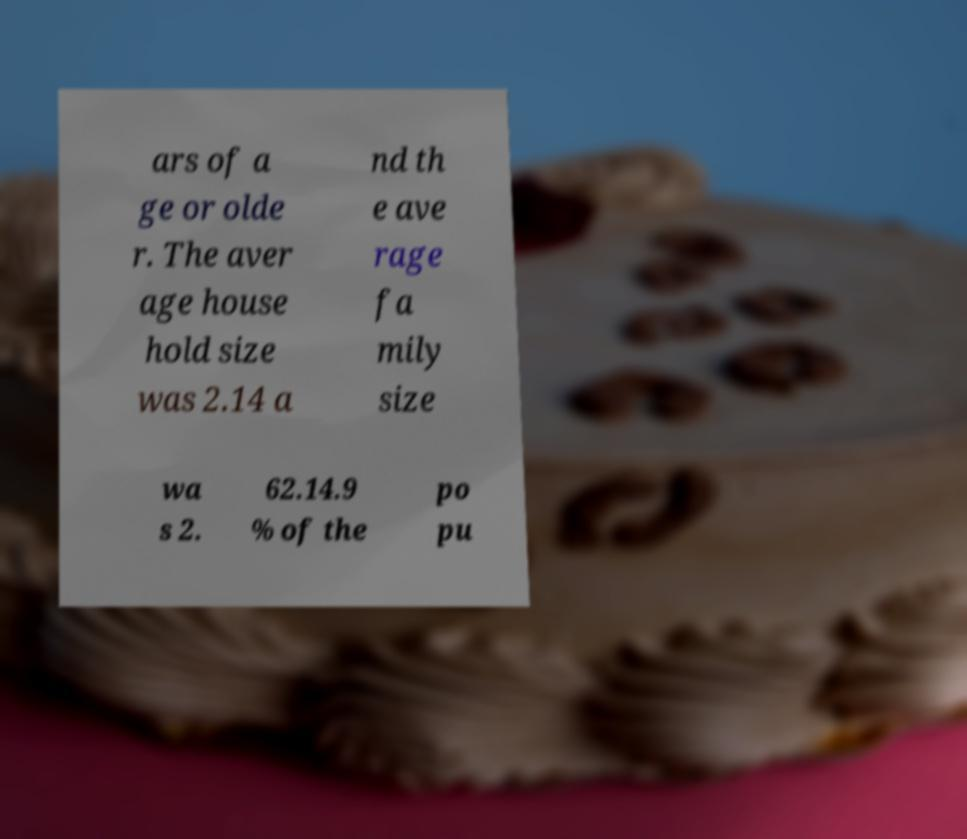Can you read and provide the text displayed in the image?This photo seems to have some interesting text. Can you extract and type it out for me? ars of a ge or olde r. The aver age house hold size was 2.14 a nd th e ave rage fa mily size wa s 2. 62.14.9 % of the po pu 